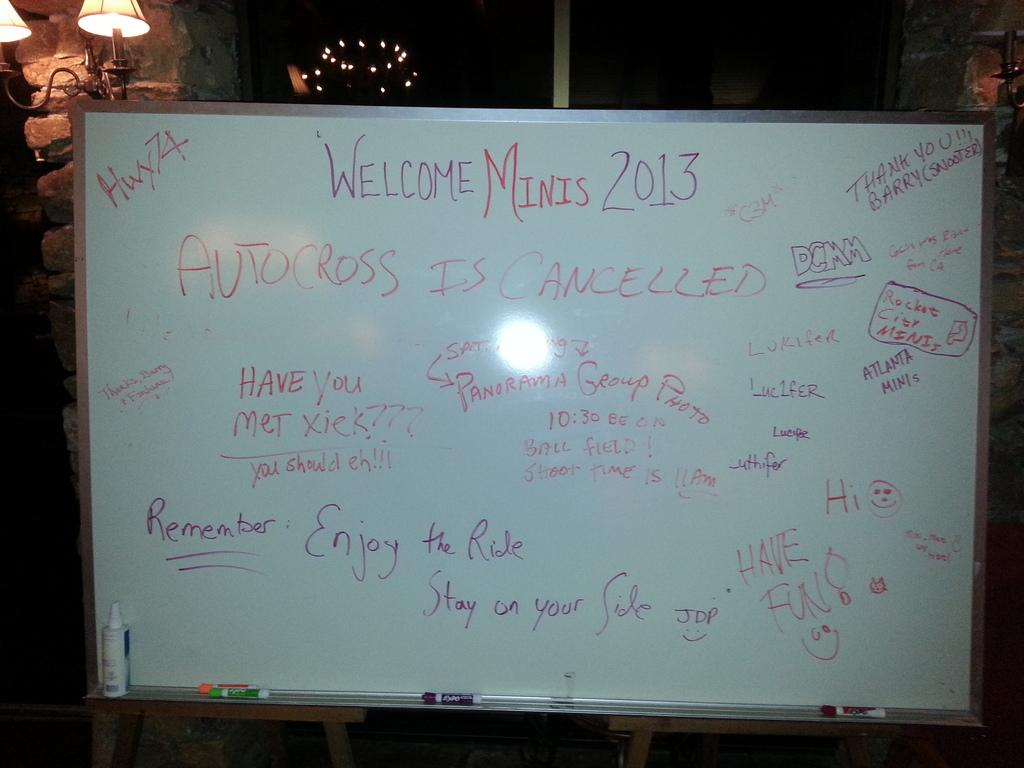What is the main object in the image? There is a whiteboard in the image. What is on the whiteboard? There is writing on the whiteboard. What additional object can be seen in the image? There is a table light visible in the image. How would you describe the overall lighting in the image? The background of the image is dark. Can you see any grass growing near the whiteboard in the image? There is no grass visible in the image; it features a whiteboard with writing and a table light. Is there a plough connected to the whiteboard in the image? There is no plough present in the image, nor is there any connection between a plough and the whiteboard. 